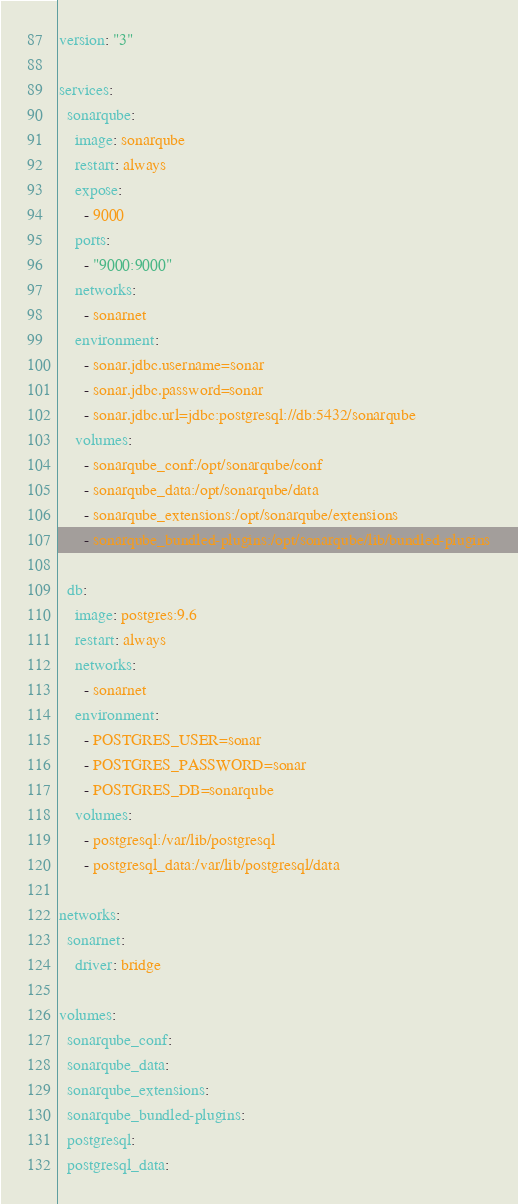Convert code to text. <code><loc_0><loc_0><loc_500><loc_500><_YAML_>version: "3"

services:
  sonarqube:
    image: sonarqube
    restart: always
    expose:
      - 9000
    ports:
      - "9000:9000"
    networks:
      - sonarnet
    environment:
      - sonar.jdbc.username=sonar
      - sonar.jdbc.password=sonar
      - sonar.jdbc.url=jdbc:postgresql://db:5432/sonarqube
    volumes:
      - sonarqube_conf:/opt/sonarqube/conf
      - sonarqube_data:/opt/sonarqube/data
      - sonarqube_extensions:/opt/sonarqube/extensions
      - sonarqube_bundled-plugins:/opt/sonarqube/lib/bundled-plugins

  db:
    image: postgres:9.6
    restart: always
    networks:
      - sonarnet
    environment:
      - POSTGRES_USER=sonar
      - POSTGRES_PASSWORD=sonar
      - POSTGRES_DB=sonarqube
    volumes:
      - postgresql:/var/lib/postgresql
      - postgresql_data:/var/lib/postgresql/data

networks:
  sonarnet:
    driver: bridge

volumes:
  sonarqube_conf:
  sonarqube_data:
  sonarqube_extensions:
  sonarqube_bundled-plugins:
  postgresql:
  postgresql_data:</code> 